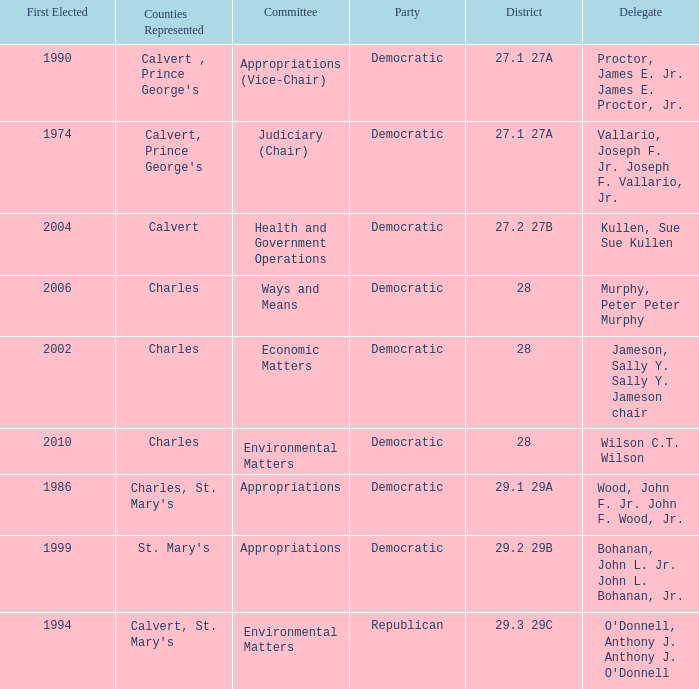When first elected was 2006, who was the delegate? Murphy, Peter Peter Murphy. 